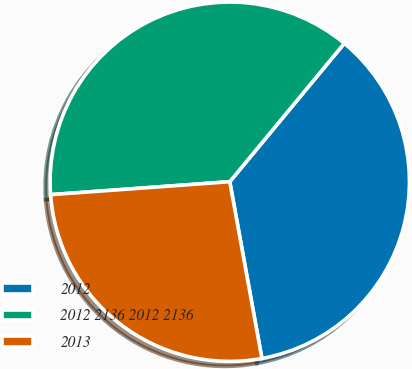<chart> <loc_0><loc_0><loc_500><loc_500><pie_chart><fcel>2012<fcel>2012 2136 2012 2136<fcel>2013<nl><fcel>36.13%<fcel>37.15%<fcel>26.71%<nl></chart> 